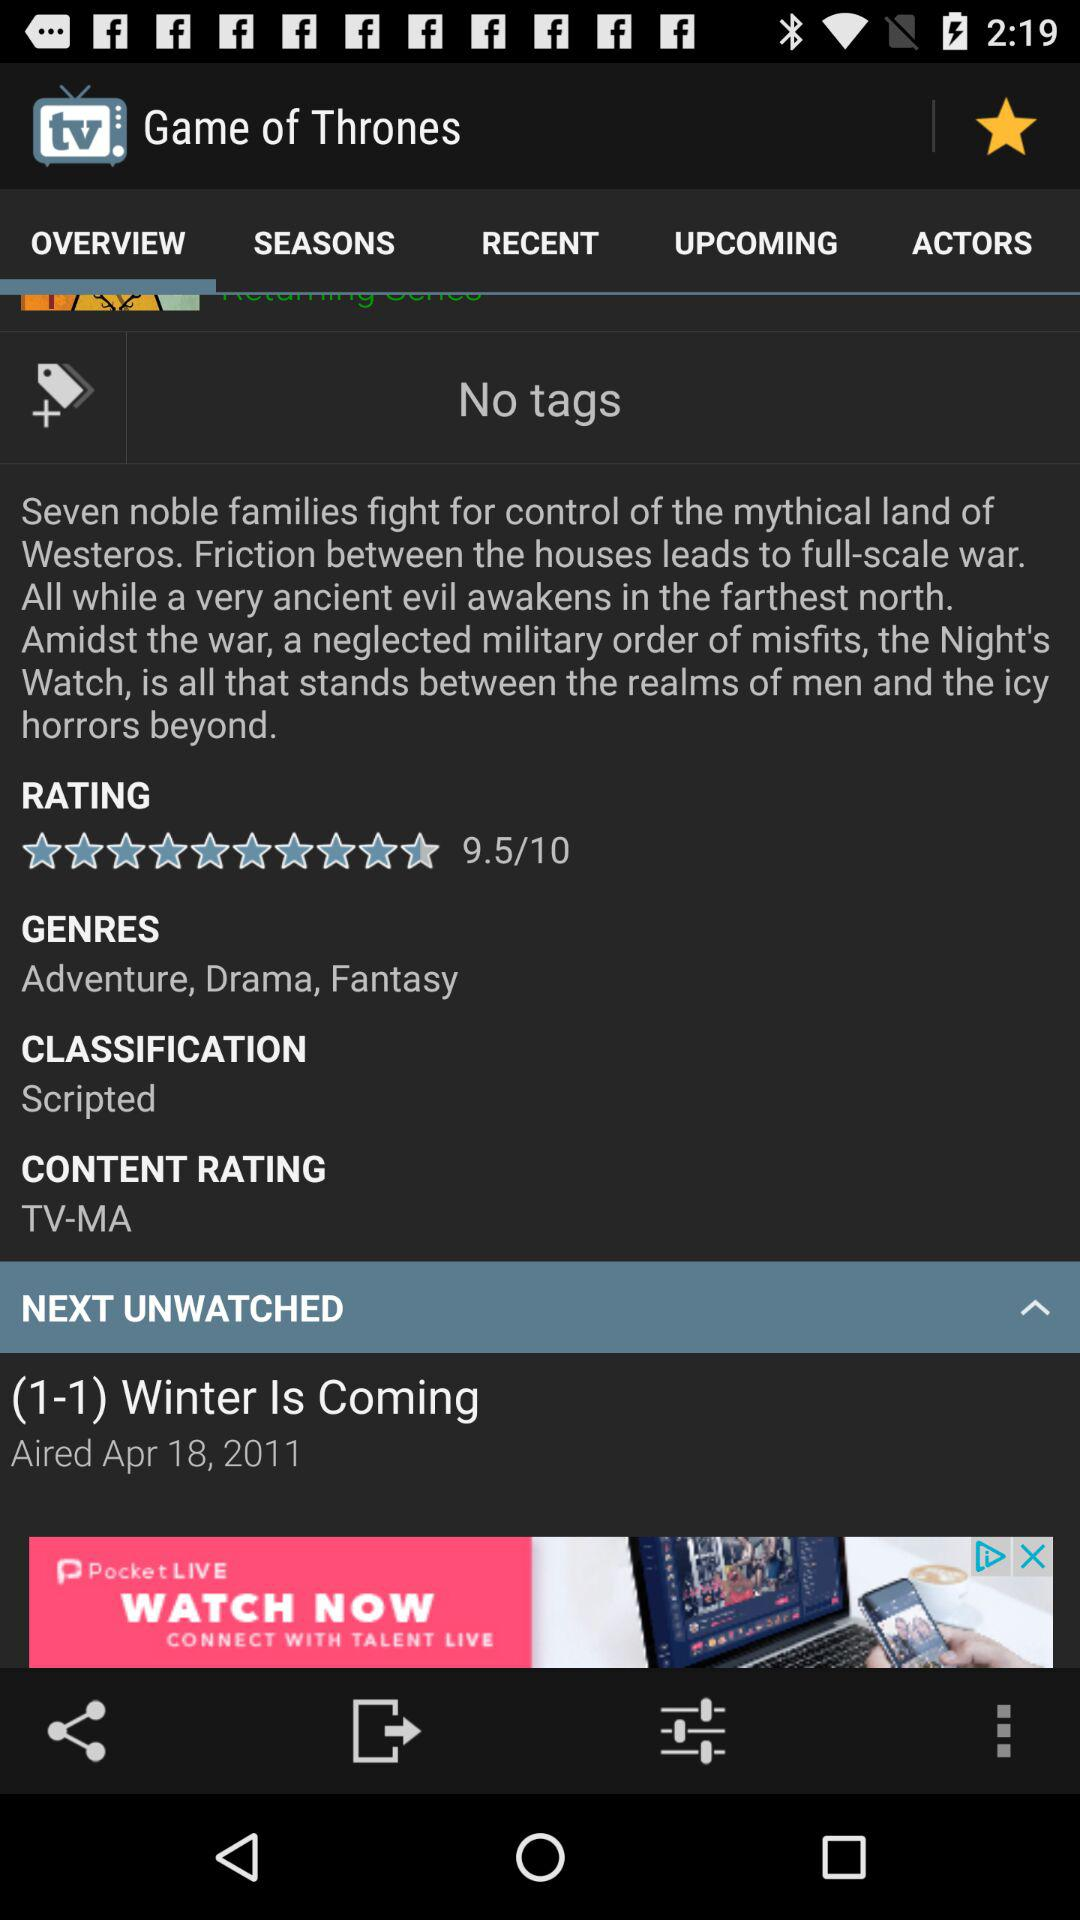What is the classification? The classification is "Scripted". 